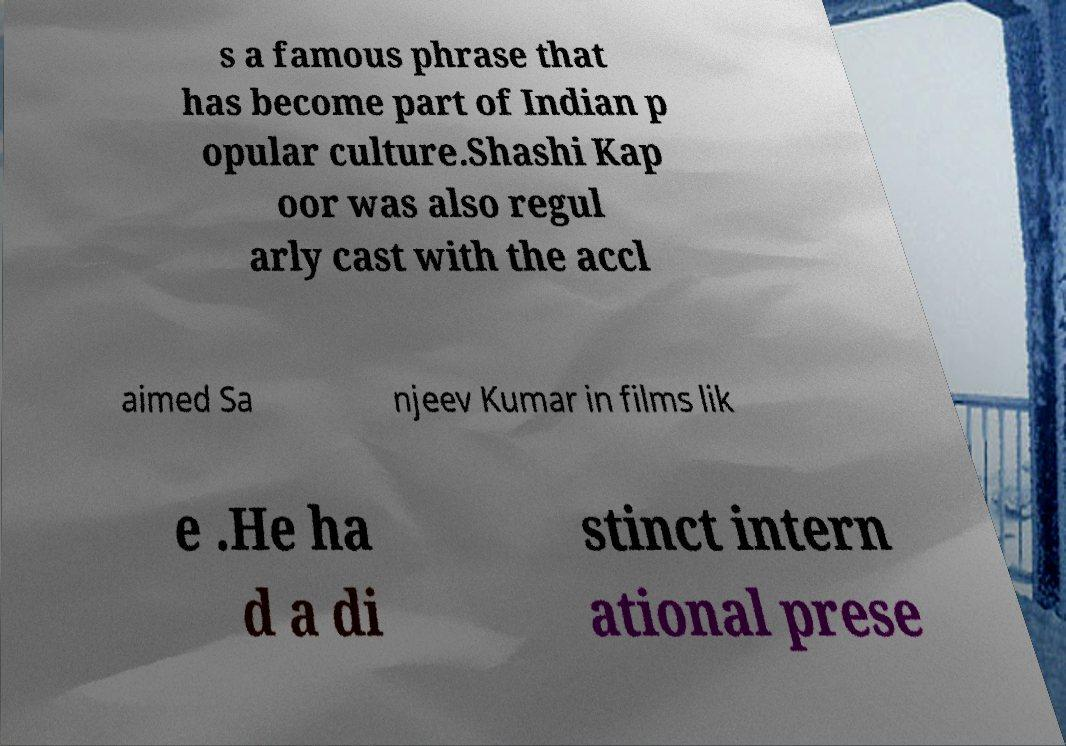Please read and relay the text visible in this image. What does it say? s a famous phrase that has become part of Indian p opular culture.Shashi Kap oor was also regul arly cast with the accl aimed Sa njeev Kumar in films lik e .He ha d a di stinct intern ational prese 